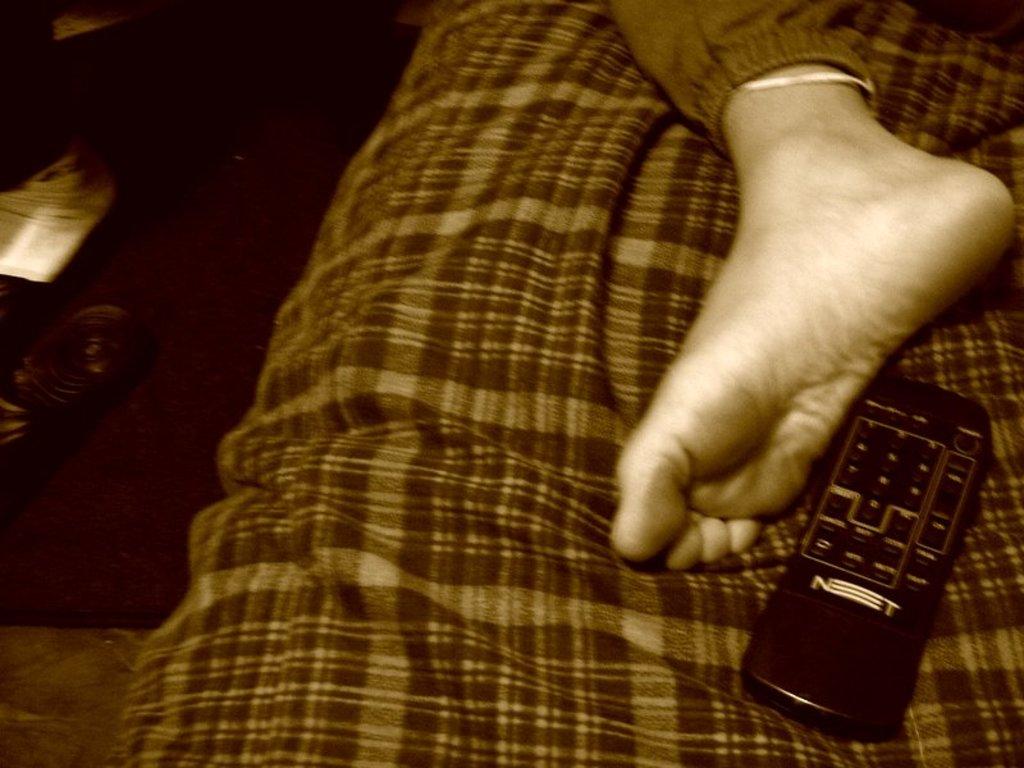What 2 letters are written in white on the remote?
Provide a short and direct response. Nt. 